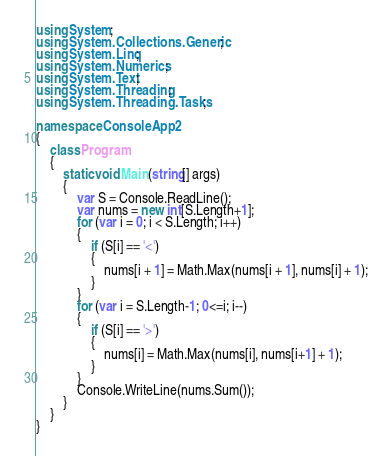Convert code to text. <code><loc_0><loc_0><loc_500><loc_500><_C#_>using System;
using System.Collections.Generic;
using System.Linq;
using System.Numerics;
using System.Text;
using System.Threading;
using System.Threading.Tasks;

namespace ConsoleApp2
{
    class Program
    {
        static void Main(string[] args)
        {
            var S = Console.ReadLine();
            var nums = new int[S.Length+1];
            for (var i = 0; i < S.Length; i++)
            {
                if (S[i] == '<')
                {
                    nums[i + 1] = Math.Max(nums[i + 1], nums[i] + 1);
                }
            }
            for (var i = S.Length-1; 0<=i; i--)
            {
                if (S[i] == '>')
                {
                    nums[i] = Math.Max(nums[i], nums[i+1] + 1);
                }
            }
            Console.WriteLine(nums.Sum());
        }
    }
}</code> 